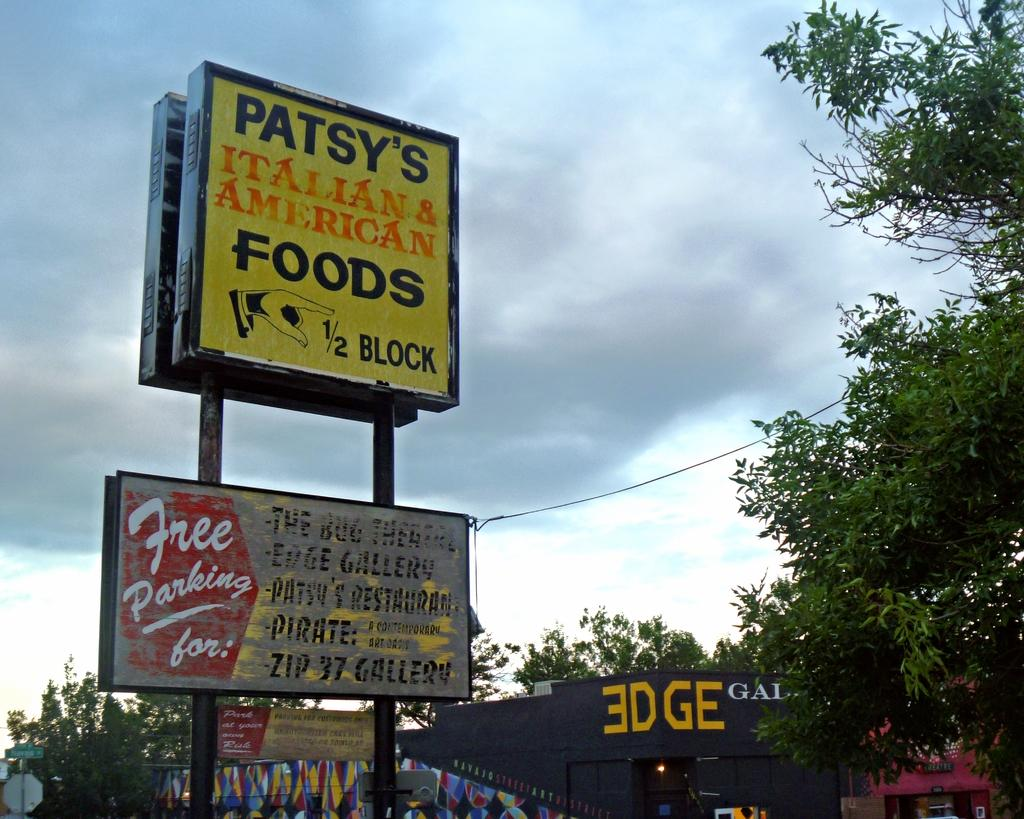Provide a one-sentence caption for the provided image. Large sign that says "Patsy's Italian & American Foods.". 